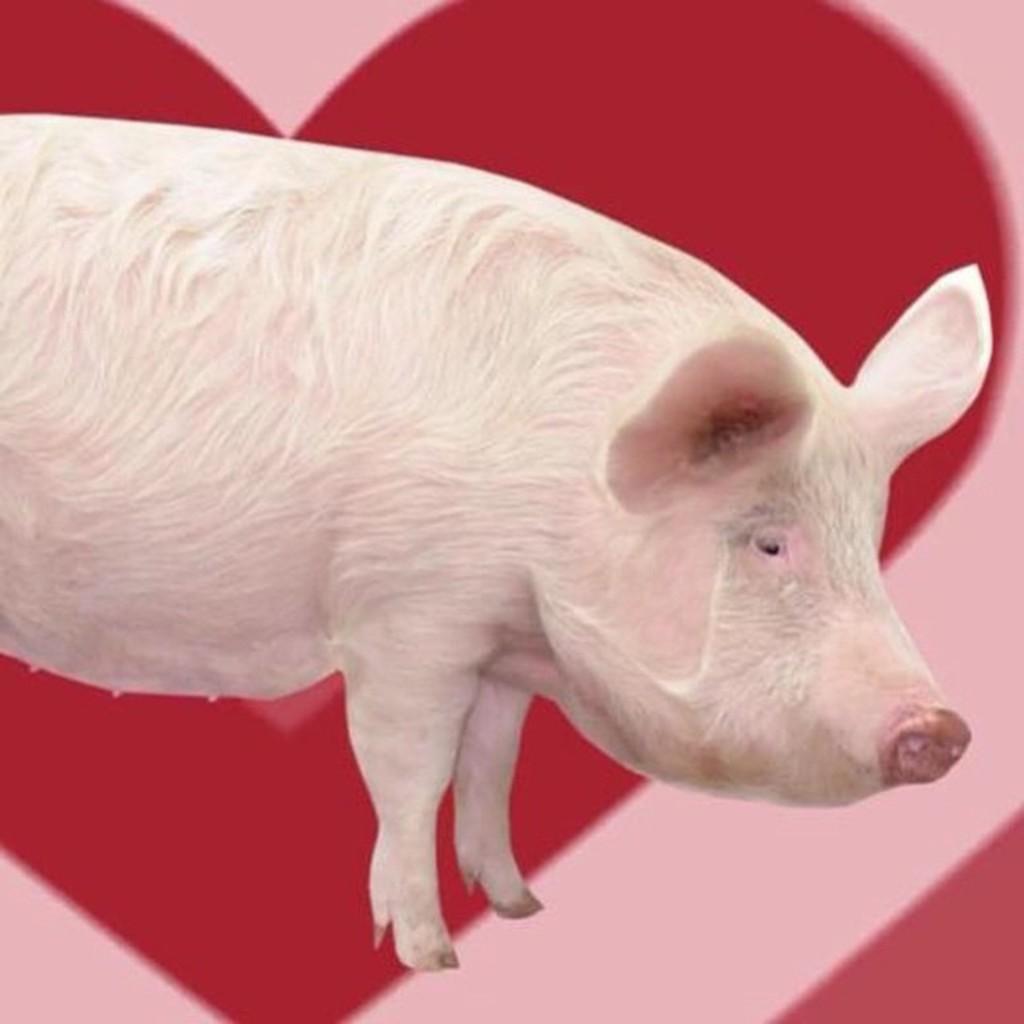How would you summarize this image in a sentence or two? This is the picture of a white pig and behind there is a poster in red and pink color. 